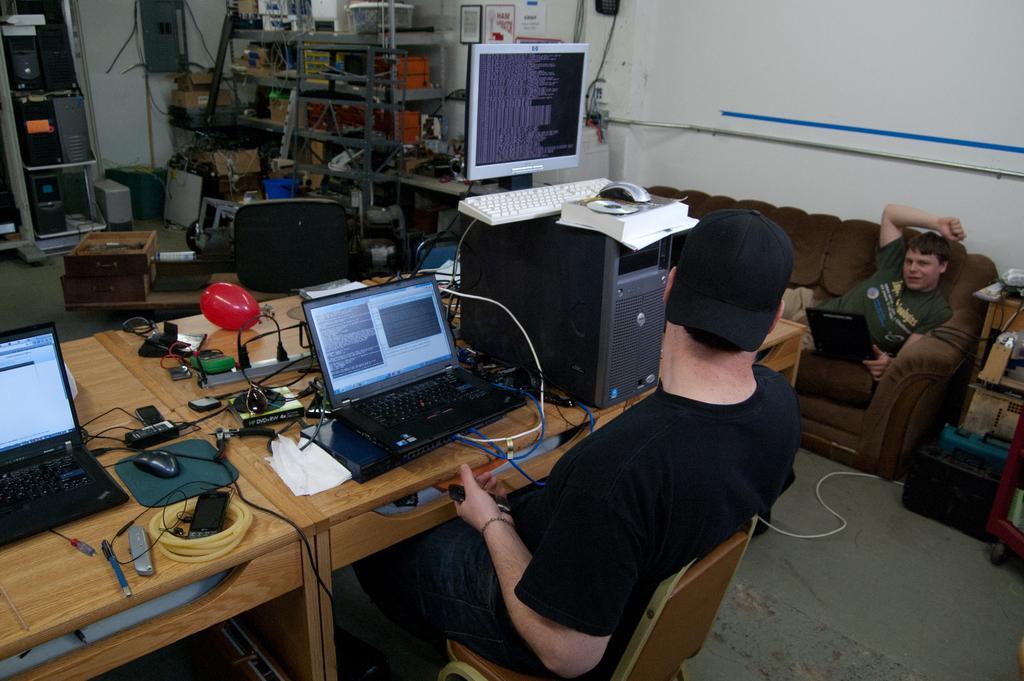Please provide a concise description of this image. In this picture we can see two people, one person is seated on the chair, and another one is seated on the sofa, in the middle of the image we can find laptops, CPU, books, balloon, mobiles on the table, and also we can see some electronic instruments in the room. 